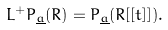<formula> <loc_0><loc_0><loc_500><loc_500>L ^ { + } P _ { \underline { a } } ( R ) = P _ { \underline { a } } ( R [ [ t ] ] ) .</formula> 